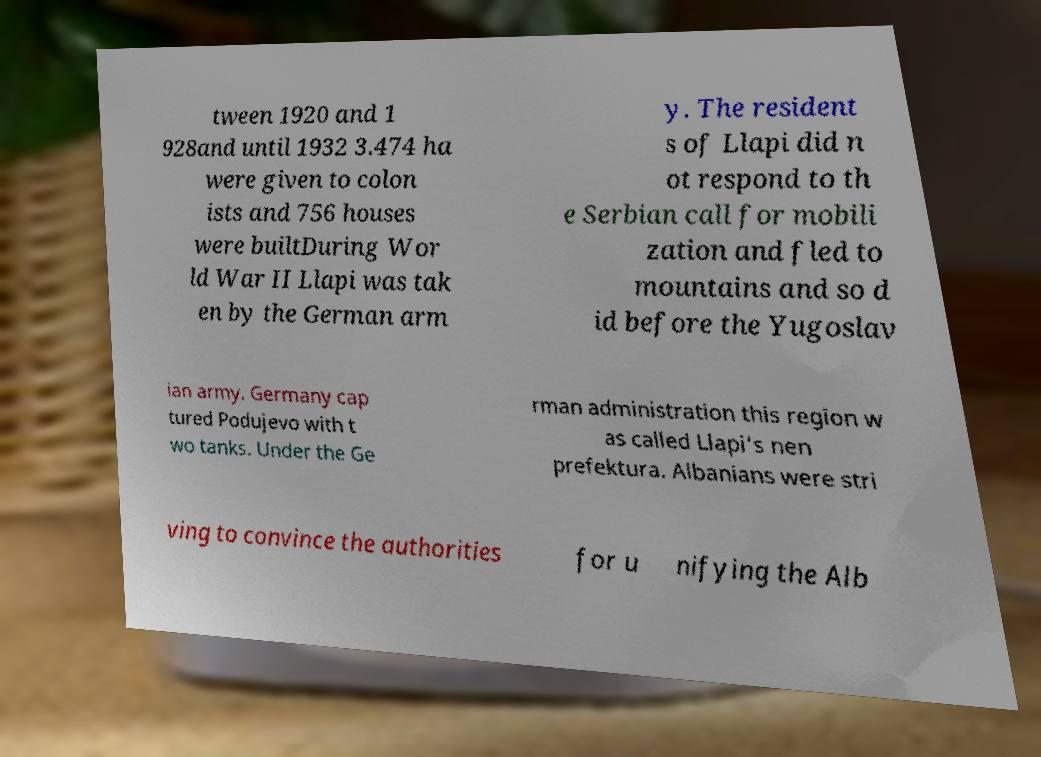Can you accurately transcribe the text from the provided image for me? tween 1920 and 1 928and until 1932 3.474 ha were given to colon ists and 756 houses were builtDuring Wor ld War II Llapi was tak en by the German arm y. The resident s of Llapi did n ot respond to th e Serbian call for mobili zation and fled to mountains and so d id before the Yugoslav ian army. Germany cap tured Podujevo with t wo tanks. Under the Ge rman administration this region w as called Llapi's nen prefektura. Albanians were stri ving to convince the authorities for u nifying the Alb 